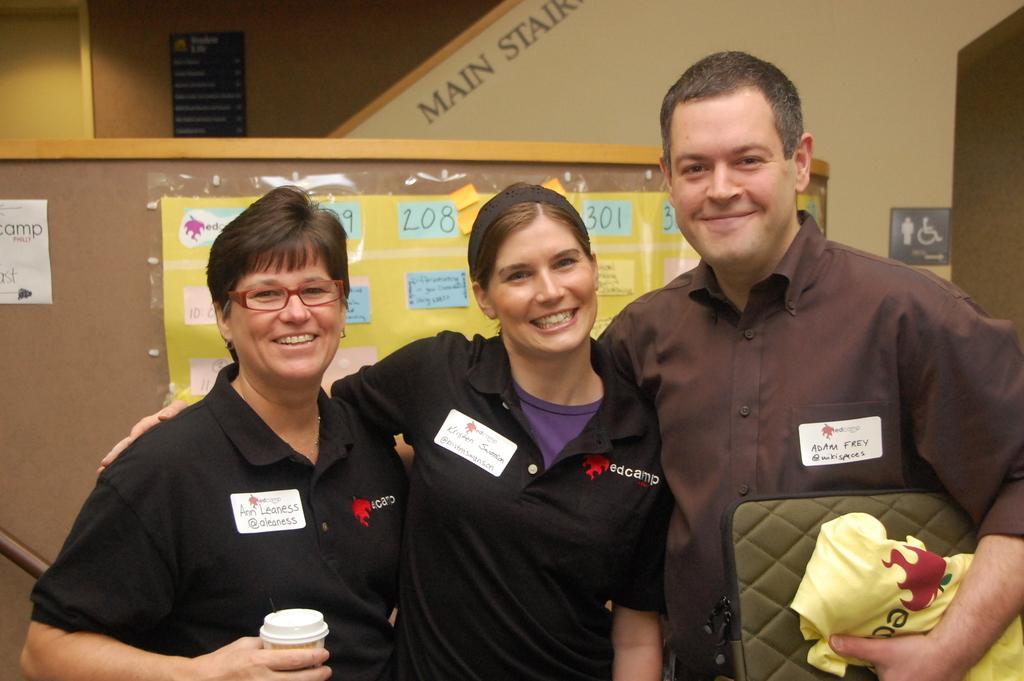How would you summarize this image in a sentence or two? Three persons are standing in a picture and 3 persons are smiling very beautifully. This man is holding his bag and cloth. This woman kept her hand on other person shoulder. These person holding cup. She has a badge. This is a board, where the information will be given. This is a yellow chart without numbers. This is a sign board. The wall is in cream color. The poster is in blue color and there is written something. 